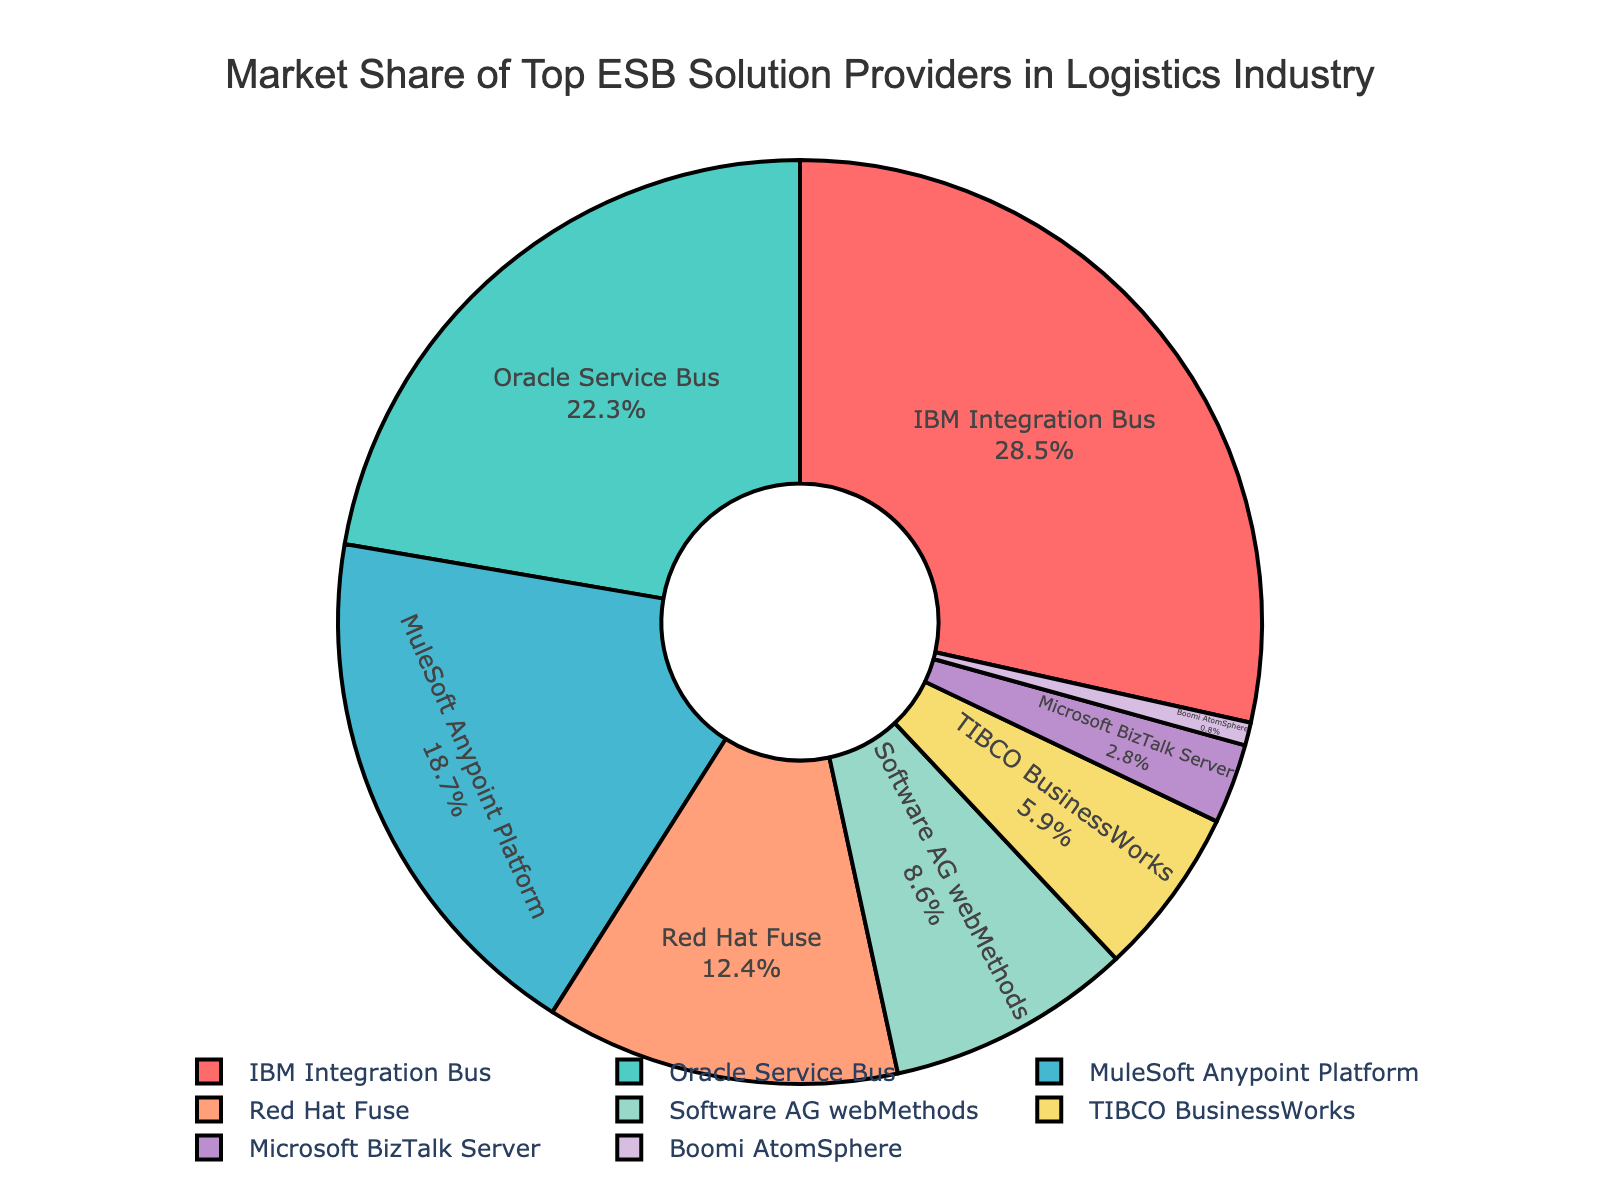What is the market share of the ESB provider with the highest market share? The figure shows the market share percentage next to each ESB provider. The provider with the highest market share is IBM Integration Bus, which holds 28.5%.
Answer: 28.5% Which ESB provider has a market share of less than 1%? By looking at the figure, only Boomi AtomSphere has a market share below 1%, which is 0.8%.
Answer: Boomi AtomSphere What is the total market share of Oracle Service Bus and Red Hat Fuse combined? The market share of Oracle Service Bus is 22.3% and that of Red Hat Fuse is 12.4%. Adding these two values together: 22.3 + 12.4 = 34.7%.
Answer: 34.7% Which ESB provider has a slightly higher market share: TIBCO BusinessWorks or Microsoft BizTalk Server? The figure shows that TIBCO BusinessWorks has a market share of 5.9%, whereas Microsoft BizTalk Server has a market share of 2.8%. Since 5.9% is greater than 2.8%, TIBCO BusinessWorks has a higher market share.
Answer: TIBCO BusinessWorks What is the combined market share of the two ESB providers with the smallest shares? The providers with the smallest market shares are Boomi AtomSphere with 0.8% and Microsoft BizTalk Server with 2.8%. Combined, their shares are 0.8 + 2.8 = 3.6%.
Answer: 3.6% How does the market share of MuleSoft Anypoint Platform compare to Red Hat Fuse? The market share of MuleSoft Anypoint Platform is 18.7%, while the market share of Red Hat Fuse is 12.4%. Comparing the two, 18.7% is higher than 12.4%.
Answer: MuleSoft Anypoint Platform has a higher market share than Red Hat Fuse Which two ESB providers have the closest market share values, and what are those values? From the figure, Oracle Service Bus has a market share of 22.3%, and MuleSoft Anypoint Platform has a market share of 18.7%. The difference between their shares is the smallest among any two ESB providers, which is 22.3 - 18.7 = 3.6%.
Answer: Oracle Service Bus (22.3%) and MuleSoft Anypoint Platform (18.7%) Which ESB provider's market share is represented by the green color in the figure? The figure uses different colors for each ESB provider's market share. Oracle Service Bus is represented by the green color.
Answer: Oracle Service Bus What is the difference in market share between the ESB provider with the highest share and the provider with the lowest share? The ESB provider with the highest share is IBM Integration Bus with 28.5%, and the provider with the lowest share is Boomi AtomSphere with 0.8%. The difference between their shares is 28.5 - 0.8 = 27.7%.
Answer: 27.7% 